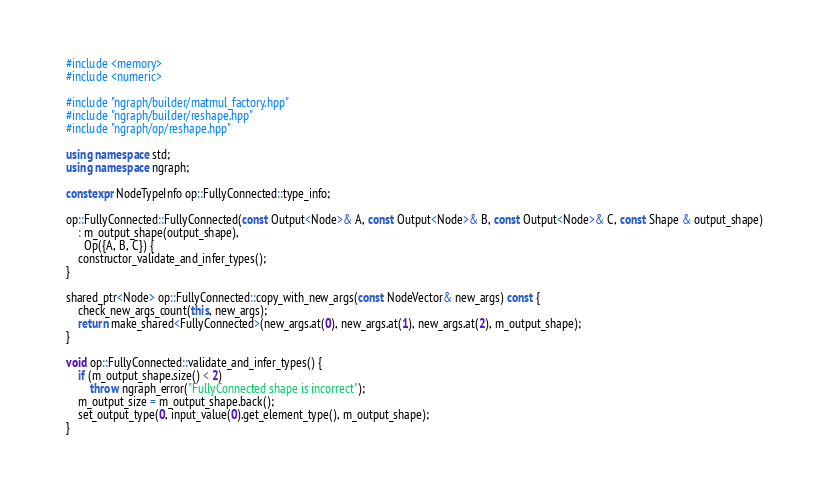Convert code to text. <code><loc_0><loc_0><loc_500><loc_500><_C++_>#include <memory>
#include <numeric>

#include "ngraph/builder/matmul_factory.hpp"
#include "ngraph/builder/reshape.hpp"
#include "ngraph/op/reshape.hpp"

using namespace std;
using namespace ngraph;

constexpr NodeTypeInfo op::FullyConnected::type_info;

op::FullyConnected::FullyConnected(const Output<Node>& A, const Output<Node>& B, const Output<Node>& C, const Shape & output_shape)
    : m_output_shape(output_shape),
      Op({A, B, C}) {
    constructor_validate_and_infer_types();
}

shared_ptr<Node> op::FullyConnected::copy_with_new_args(const NodeVector& new_args) const {
    check_new_args_count(this, new_args);
    return make_shared<FullyConnected>(new_args.at(0), new_args.at(1), new_args.at(2), m_output_shape);
}

void op::FullyConnected::validate_and_infer_types() {
    if (m_output_shape.size() < 2)
        throw ngraph_error("FullyConnected shape is incorrect");
    m_output_size = m_output_shape.back();
    set_output_type(0, input_value(0).get_element_type(), m_output_shape);
}
</code> 